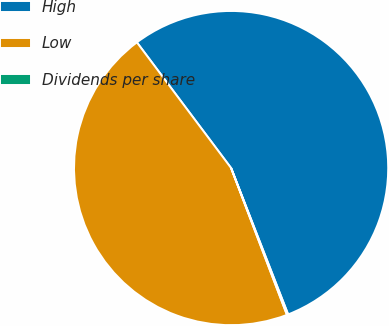Convert chart. <chart><loc_0><loc_0><loc_500><loc_500><pie_chart><fcel>High<fcel>Low<fcel>Dividends per share<nl><fcel>54.33%<fcel>45.55%<fcel>0.13%<nl></chart> 